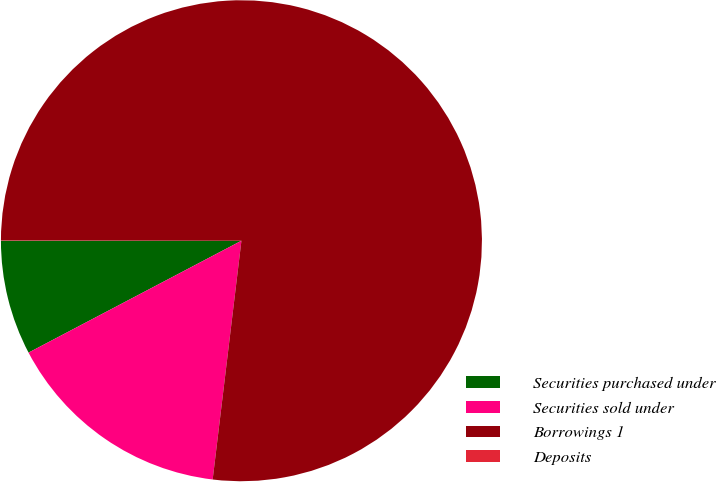Convert chart to OTSL. <chart><loc_0><loc_0><loc_500><loc_500><pie_chart><fcel>Securities purchased under<fcel>Securities sold under<fcel>Borrowings 1<fcel>Deposits<nl><fcel>7.7%<fcel>15.39%<fcel>76.89%<fcel>0.02%<nl></chart> 